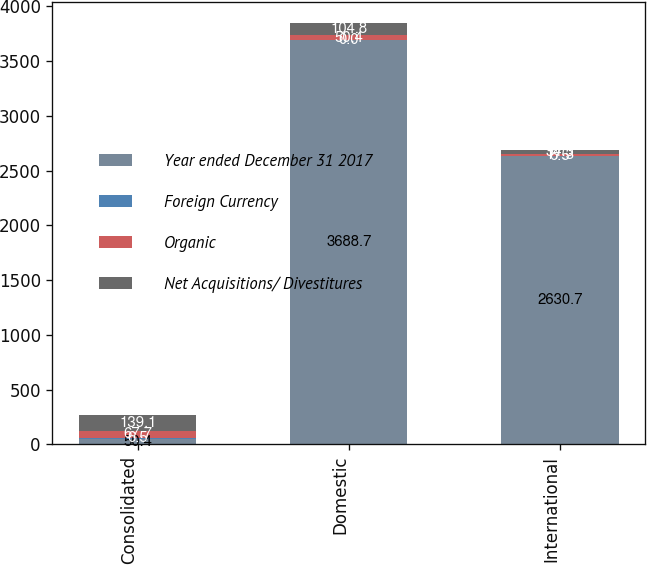<chart> <loc_0><loc_0><loc_500><loc_500><stacked_bar_chart><ecel><fcel>Consolidated<fcel>Domestic<fcel>International<nl><fcel>Year ended December 31 2017<fcel>50.4<fcel>3688.7<fcel>2630.7<nl><fcel>Foreign Currency<fcel>6.5<fcel>0<fcel>6.5<nl><fcel>Organic<fcel>67.7<fcel>50.4<fcel>17.3<nl><fcel>Net Acquisitions/ Divestitures<fcel>139.1<fcel>104.8<fcel>34.3<nl></chart> 